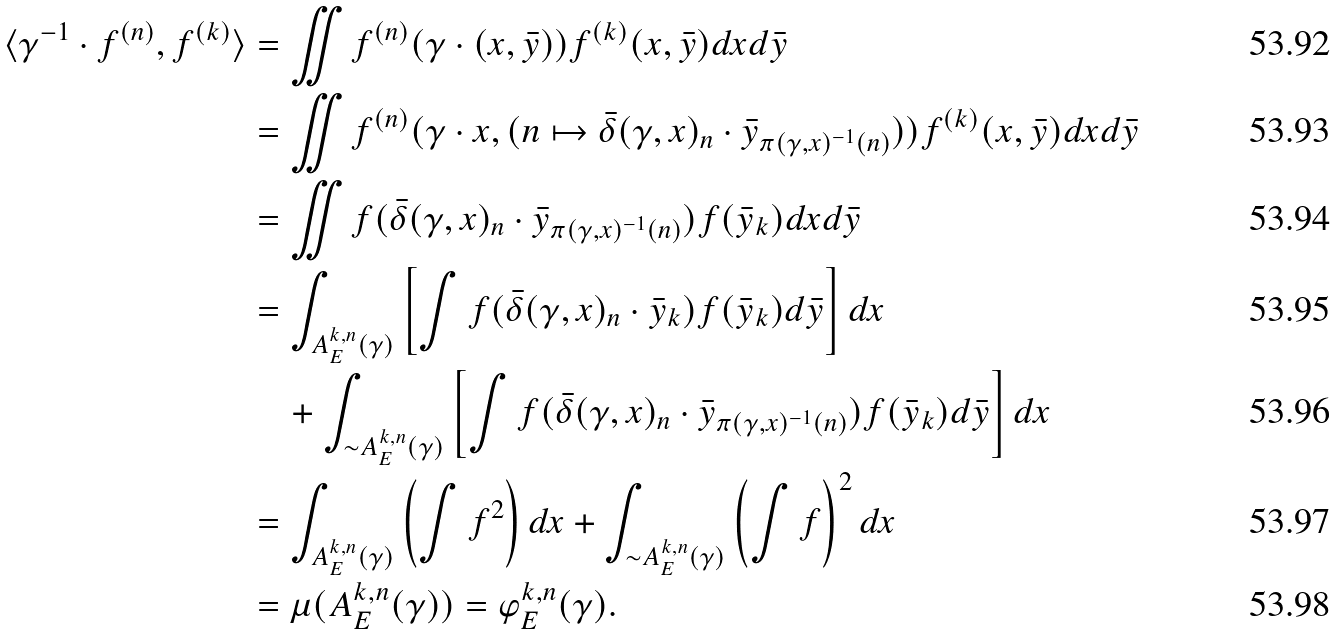<formula> <loc_0><loc_0><loc_500><loc_500>\langle \gamma ^ { - 1 } \cdot f ^ { ( n ) } , f ^ { ( k ) } \rangle & = \iint f ^ { ( n ) } ( \gamma \cdot ( x , \bar { y } ) ) f ^ { ( k ) } ( x , \bar { y } ) d x d \bar { y } \\ & = \iint f ^ { ( n ) } ( \gamma \cdot x , ( n \mapsto \bar { \delta } ( \gamma , x ) _ { n } \cdot \bar { y } _ { \pi ( \gamma , x ) ^ { - 1 } ( n ) } ) ) f ^ { ( k ) } ( x , \bar { y } ) d x d \bar { y } \\ & = \iint f ( \bar { \delta } ( \gamma , x ) _ { n } \cdot \bar { y } _ { \pi ( \gamma , x ) ^ { - 1 } ( n ) } ) f ( \bar { y } _ { k } ) d x d \bar { y } \\ & = \int _ { A ^ { k , n } _ { E } ( \gamma ) } \left [ \int f ( \bar { \delta } ( \gamma , x ) _ { n } \cdot \bar { y } _ { k } ) f ( \bar { y } _ { k } ) d \bar { y } \right ] d x \\ & \quad + \int _ { \sim A ^ { k , n } _ { E } ( \gamma ) } \left [ \int f ( \bar { \delta } ( \gamma , x ) _ { n } \cdot \bar { y } _ { \pi ( \gamma , x ) ^ { - 1 } ( n ) } ) f ( \bar { y } _ { k } ) d \bar { y } \right ] d x \\ & = \int _ { A ^ { k , n } _ { E } ( \gamma ) } \left ( \int f ^ { 2 } \right ) d x + \int _ { \sim A ^ { k , n } _ { E } ( \gamma ) } \left ( \int f \right ) ^ { 2 } d x \\ & = \mu ( A ^ { k , n } _ { E } ( \gamma ) ) = \varphi ^ { k , n } _ { E } ( \gamma ) .</formula> 